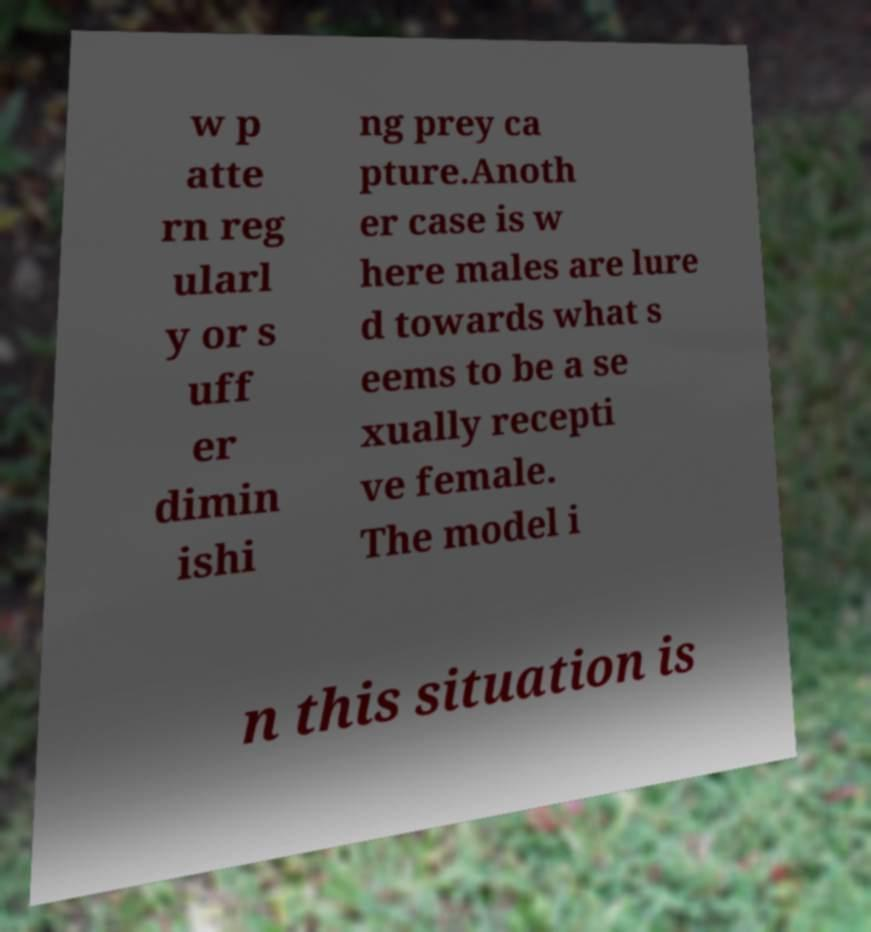Can you accurately transcribe the text from the provided image for me? w p atte rn reg ularl y or s uff er dimin ishi ng prey ca pture.Anoth er case is w here males are lure d towards what s eems to be a se xually recepti ve female. The model i n this situation is 